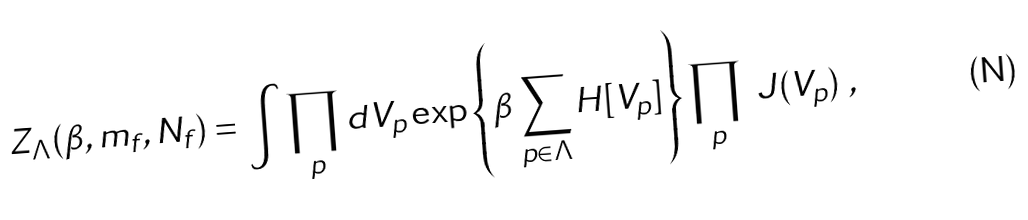<formula> <loc_0><loc_0><loc_500><loc_500>Z _ { \Lambda } ( \beta , m _ { f } , N _ { f } ) = \int \prod _ { p } d V _ { p } \exp \left \{ \beta \sum _ { p \in \Lambda } H [ V _ { p } ] \right \} \prod _ { p } \ J ( V _ { p } ) \ ,</formula> 